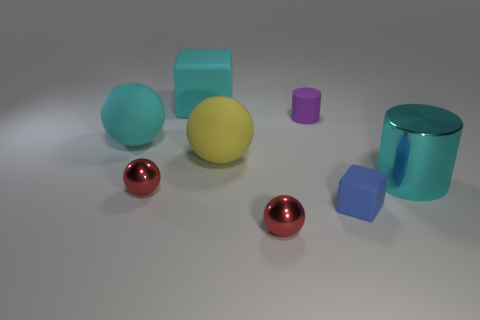Subtract all large cyan rubber balls. How many balls are left? 3 Add 2 red matte blocks. How many objects exist? 10 Subtract all purple cylinders. How many red balls are left? 2 Subtract all red balls. How many balls are left? 2 Subtract all cubes. How many objects are left? 6 Subtract all purple blocks. Subtract all green cylinders. How many blocks are left? 2 Subtract all large brown metal blocks. Subtract all large cyan shiny objects. How many objects are left? 7 Add 1 big cyan cylinders. How many big cyan cylinders are left? 2 Add 1 big gray rubber cubes. How many big gray rubber cubes exist? 1 Subtract 0 gray cylinders. How many objects are left? 8 